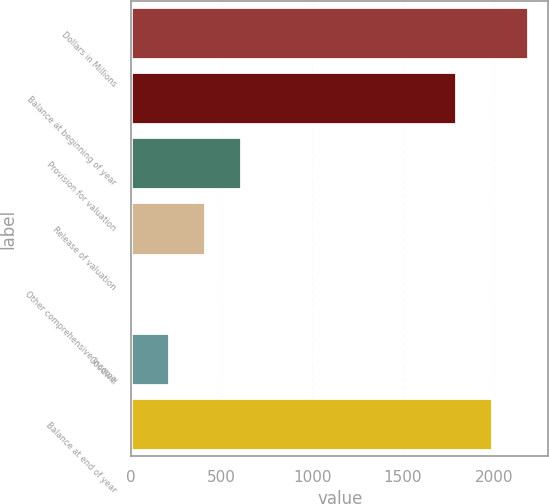Convert chart. <chart><loc_0><loc_0><loc_500><loc_500><bar_chart><fcel>Dollars in Millions<fcel>Balance at beginning of year<fcel>Provision for valuation<fcel>Release of valuation<fcel>Other comprehensive income<fcel>Goodwill<fcel>Balance at end of year<nl><fcel>2191.8<fcel>1791<fcel>607.2<fcel>406.8<fcel>6<fcel>206.4<fcel>1991.4<nl></chart> 